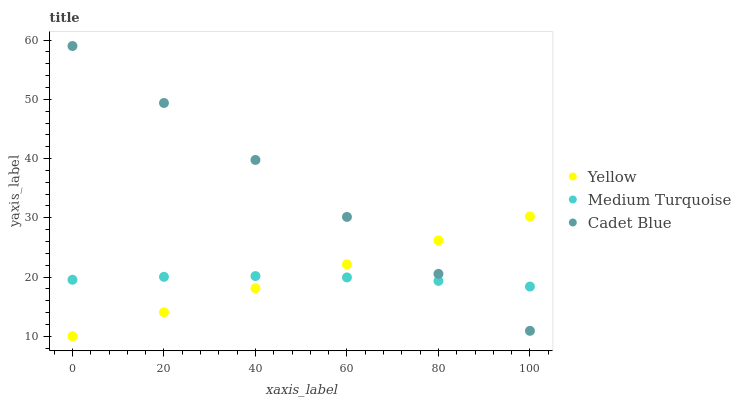Does Medium Turquoise have the minimum area under the curve?
Answer yes or no. Yes. Does Cadet Blue have the maximum area under the curve?
Answer yes or no. Yes. Does Yellow have the minimum area under the curve?
Answer yes or no. No. Does Yellow have the maximum area under the curve?
Answer yes or no. No. Is Yellow the smoothest?
Answer yes or no. Yes. Is Medium Turquoise the roughest?
Answer yes or no. Yes. Is Medium Turquoise the smoothest?
Answer yes or no. No. Is Yellow the roughest?
Answer yes or no. No. Does Yellow have the lowest value?
Answer yes or no. Yes. Does Medium Turquoise have the lowest value?
Answer yes or no. No. Does Cadet Blue have the highest value?
Answer yes or no. Yes. Does Yellow have the highest value?
Answer yes or no. No. Does Cadet Blue intersect Medium Turquoise?
Answer yes or no. Yes. Is Cadet Blue less than Medium Turquoise?
Answer yes or no. No. Is Cadet Blue greater than Medium Turquoise?
Answer yes or no. No. 